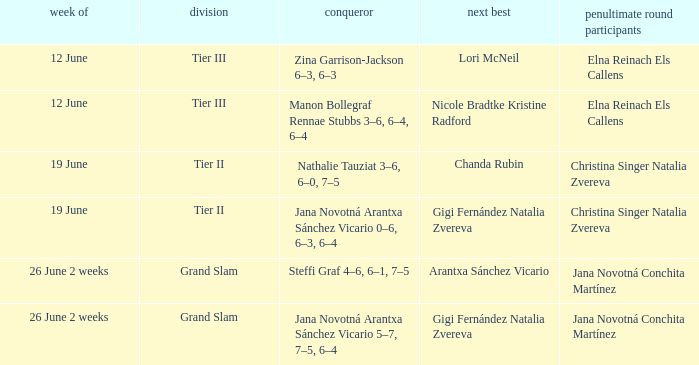Who are the semi finalists on the week of 12 june, when the runner-up is listed as Lori McNeil? Elna Reinach Els Callens. 